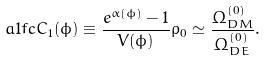Convert formula to latex. <formula><loc_0><loc_0><loc_500><loc_500>\sl a { 1 f c } C _ { 1 } { ( \phi ) } \equiv \frac { e ^ { \alpha ( \phi ) } - 1 } { V ( \phi ) } \rho _ { 0 } \simeq \frac { \Omega ^ { ( 0 ) } _ { D M } } { \Omega ^ { ( 0 ) } _ { D E } } .</formula> 